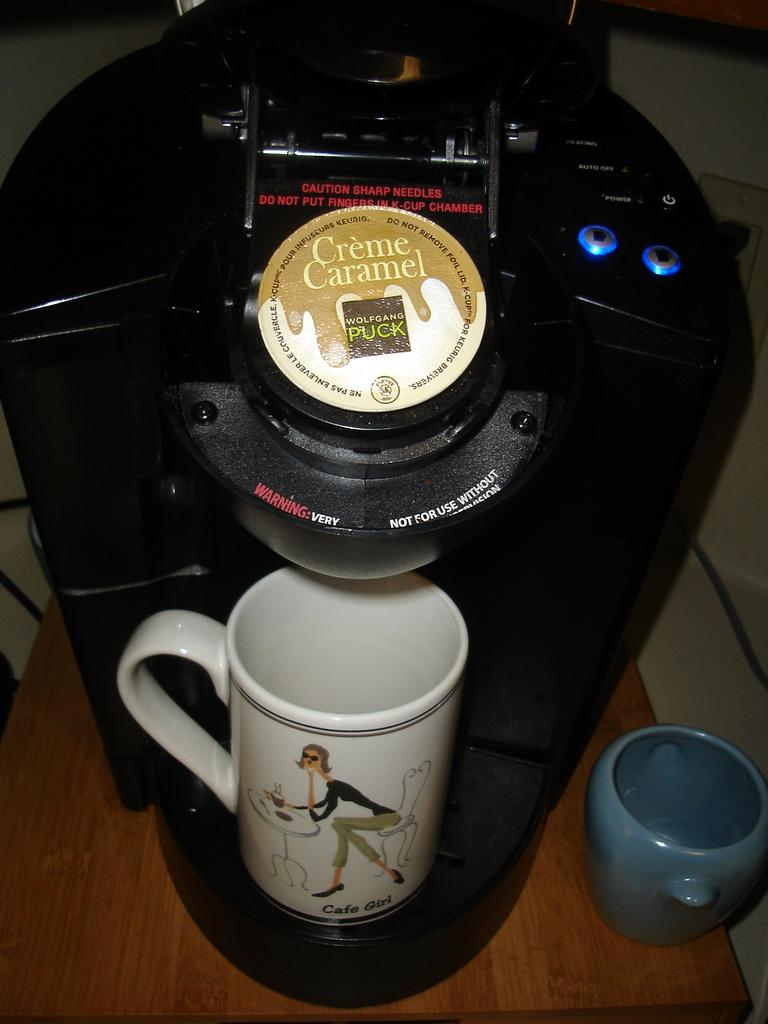<image>
Write a terse but informative summary of the picture. A coffee cup with Cafe Girl on it is placed in a coffee maker tray. 